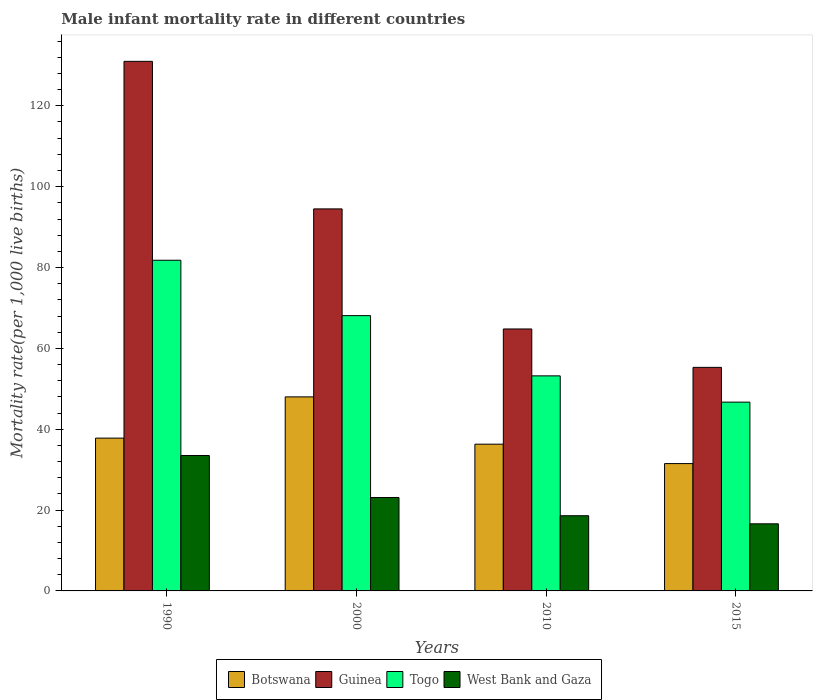How many groups of bars are there?
Offer a very short reply. 4. Are the number of bars on each tick of the X-axis equal?
Provide a short and direct response. Yes. What is the label of the 3rd group of bars from the left?
Offer a terse response. 2010. In how many cases, is the number of bars for a given year not equal to the number of legend labels?
Ensure brevity in your answer.  0. What is the male infant mortality rate in Togo in 2000?
Offer a very short reply. 68.1. Across all years, what is the maximum male infant mortality rate in Botswana?
Provide a succinct answer. 48. Across all years, what is the minimum male infant mortality rate in Botswana?
Your answer should be compact. 31.5. In which year was the male infant mortality rate in Guinea maximum?
Keep it short and to the point. 1990. In which year was the male infant mortality rate in West Bank and Gaza minimum?
Give a very brief answer. 2015. What is the total male infant mortality rate in Guinea in the graph?
Offer a terse response. 345.6. What is the difference between the male infant mortality rate in Togo in 2000 and that in 2015?
Your answer should be very brief. 21.4. What is the difference between the male infant mortality rate in West Bank and Gaza in 2000 and the male infant mortality rate in Guinea in 2015?
Your response must be concise. -32.2. What is the average male infant mortality rate in West Bank and Gaza per year?
Provide a short and direct response. 22.95. In the year 2000, what is the difference between the male infant mortality rate in Togo and male infant mortality rate in Botswana?
Your answer should be very brief. 20.1. In how many years, is the male infant mortality rate in Botswana greater than 72?
Give a very brief answer. 0. What is the ratio of the male infant mortality rate in West Bank and Gaza in 2000 to that in 2015?
Give a very brief answer. 1.39. Is the male infant mortality rate in Guinea in 1990 less than that in 2000?
Provide a short and direct response. No. Is the difference between the male infant mortality rate in Togo in 2000 and 2015 greater than the difference between the male infant mortality rate in Botswana in 2000 and 2015?
Your answer should be very brief. Yes. What is the difference between the highest and the second highest male infant mortality rate in West Bank and Gaza?
Offer a very short reply. 10.4. What is the difference between the highest and the lowest male infant mortality rate in Guinea?
Offer a terse response. 75.7. Is the sum of the male infant mortality rate in Guinea in 1990 and 2010 greater than the maximum male infant mortality rate in Botswana across all years?
Your response must be concise. Yes. What does the 1st bar from the left in 2010 represents?
Provide a short and direct response. Botswana. What does the 4th bar from the right in 1990 represents?
Your answer should be compact. Botswana. How many bars are there?
Your answer should be very brief. 16. Are the values on the major ticks of Y-axis written in scientific E-notation?
Offer a very short reply. No. Does the graph contain any zero values?
Offer a very short reply. No. Where does the legend appear in the graph?
Ensure brevity in your answer.  Bottom center. What is the title of the graph?
Ensure brevity in your answer.  Male infant mortality rate in different countries. Does "Jordan" appear as one of the legend labels in the graph?
Give a very brief answer. No. What is the label or title of the X-axis?
Your response must be concise. Years. What is the label or title of the Y-axis?
Provide a short and direct response. Mortality rate(per 1,0 live births). What is the Mortality rate(per 1,000 live births) in Botswana in 1990?
Keep it short and to the point. 37.8. What is the Mortality rate(per 1,000 live births) of Guinea in 1990?
Provide a succinct answer. 131. What is the Mortality rate(per 1,000 live births) of Togo in 1990?
Provide a succinct answer. 81.8. What is the Mortality rate(per 1,000 live births) of West Bank and Gaza in 1990?
Your response must be concise. 33.5. What is the Mortality rate(per 1,000 live births) in Guinea in 2000?
Provide a succinct answer. 94.5. What is the Mortality rate(per 1,000 live births) in Togo in 2000?
Offer a very short reply. 68.1. What is the Mortality rate(per 1,000 live births) of West Bank and Gaza in 2000?
Your response must be concise. 23.1. What is the Mortality rate(per 1,000 live births) of Botswana in 2010?
Make the answer very short. 36.3. What is the Mortality rate(per 1,000 live births) of Guinea in 2010?
Keep it short and to the point. 64.8. What is the Mortality rate(per 1,000 live births) of Togo in 2010?
Offer a very short reply. 53.2. What is the Mortality rate(per 1,000 live births) in Botswana in 2015?
Offer a terse response. 31.5. What is the Mortality rate(per 1,000 live births) in Guinea in 2015?
Your response must be concise. 55.3. What is the Mortality rate(per 1,000 live births) of Togo in 2015?
Offer a terse response. 46.7. What is the Mortality rate(per 1,000 live births) of West Bank and Gaza in 2015?
Your response must be concise. 16.6. Across all years, what is the maximum Mortality rate(per 1,000 live births) in Guinea?
Keep it short and to the point. 131. Across all years, what is the maximum Mortality rate(per 1,000 live births) of Togo?
Ensure brevity in your answer.  81.8. Across all years, what is the maximum Mortality rate(per 1,000 live births) of West Bank and Gaza?
Keep it short and to the point. 33.5. Across all years, what is the minimum Mortality rate(per 1,000 live births) of Botswana?
Provide a short and direct response. 31.5. Across all years, what is the minimum Mortality rate(per 1,000 live births) of Guinea?
Provide a short and direct response. 55.3. Across all years, what is the minimum Mortality rate(per 1,000 live births) in Togo?
Give a very brief answer. 46.7. What is the total Mortality rate(per 1,000 live births) in Botswana in the graph?
Give a very brief answer. 153.6. What is the total Mortality rate(per 1,000 live births) in Guinea in the graph?
Offer a terse response. 345.6. What is the total Mortality rate(per 1,000 live births) in Togo in the graph?
Give a very brief answer. 249.8. What is the total Mortality rate(per 1,000 live births) in West Bank and Gaza in the graph?
Give a very brief answer. 91.8. What is the difference between the Mortality rate(per 1,000 live births) in Botswana in 1990 and that in 2000?
Your answer should be very brief. -10.2. What is the difference between the Mortality rate(per 1,000 live births) of Guinea in 1990 and that in 2000?
Provide a short and direct response. 36.5. What is the difference between the Mortality rate(per 1,000 live births) in Togo in 1990 and that in 2000?
Your answer should be very brief. 13.7. What is the difference between the Mortality rate(per 1,000 live births) of West Bank and Gaza in 1990 and that in 2000?
Provide a short and direct response. 10.4. What is the difference between the Mortality rate(per 1,000 live births) of Botswana in 1990 and that in 2010?
Ensure brevity in your answer.  1.5. What is the difference between the Mortality rate(per 1,000 live births) in Guinea in 1990 and that in 2010?
Keep it short and to the point. 66.2. What is the difference between the Mortality rate(per 1,000 live births) of Togo in 1990 and that in 2010?
Provide a short and direct response. 28.6. What is the difference between the Mortality rate(per 1,000 live births) in West Bank and Gaza in 1990 and that in 2010?
Make the answer very short. 14.9. What is the difference between the Mortality rate(per 1,000 live births) of Guinea in 1990 and that in 2015?
Provide a short and direct response. 75.7. What is the difference between the Mortality rate(per 1,000 live births) in Togo in 1990 and that in 2015?
Give a very brief answer. 35.1. What is the difference between the Mortality rate(per 1,000 live births) of Botswana in 2000 and that in 2010?
Your response must be concise. 11.7. What is the difference between the Mortality rate(per 1,000 live births) of Guinea in 2000 and that in 2010?
Offer a very short reply. 29.7. What is the difference between the Mortality rate(per 1,000 live births) of Togo in 2000 and that in 2010?
Offer a terse response. 14.9. What is the difference between the Mortality rate(per 1,000 live births) of West Bank and Gaza in 2000 and that in 2010?
Offer a very short reply. 4.5. What is the difference between the Mortality rate(per 1,000 live births) in Botswana in 2000 and that in 2015?
Your answer should be compact. 16.5. What is the difference between the Mortality rate(per 1,000 live births) of Guinea in 2000 and that in 2015?
Your response must be concise. 39.2. What is the difference between the Mortality rate(per 1,000 live births) of Togo in 2000 and that in 2015?
Your answer should be very brief. 21.4. What is the difference between the Mortality rate(per 1,000 live births) in Guinea in 2010 and that in 2015?
Ensure brevity in your answer.  9.5. What is the difference between the Mortality rate(per 1,000 live births) of Togo in 2010 and that in 2015?
Provide a short and direct response. 6.5. What is the difference between the Mortality rate(per 1,000 live births) of Botswana in 1990 and the Mortality rate(per 1,000 live births) of Guinea in 2000?
Provide a short and direct response. -56.7. What is the difference between the Mortality rate(per 1,000 live births) in Botswana in 1990 and the Mortality rate(per 1,000 live births) in Togo in 2000?
Your answer should be compact. -30.3. What is the difference between the Mortality rate(per 1,000 live births) in Botswana in 1990 and the Mortality rate(per 1,000 live births) in West Bank and Gaza in 2000?
Your answer should be very brief. 14.7. What is the difference between the Mortality rate(per 1,000 live births) of Guinea in 1990 and the Mortality rate(per 1,000 live births) of Togo in 2000?
Ensure brevity in your answer.  62.9. What is the difference between the Mortality rate(per 1,000 live births) of Guinea in 1990 and the Mortality rate(per 1,000 live births) of West Bank and Gaza in 2000?
Provide a short and direct response. 107.9. What is the difference between the Mortality rate(per 1,000 live births) in Togo in 1990 and the Mortality rate(per 1,000 live births) in West Bank and Gaza in 2000?
Offer a terse response. 58.7. What is the difference between the Mortality rate(per 1,000 live births) in Botswana in 1990 and the Mortality rate(per 1,000 live births) in Guinea in 2010?
Provide a succinct answer. -27. What is the difference between the Mortality rate(per 1,000 live births) in Botswana in 1990 and the Mortality rate(per 1,000 live births) in Togo in 2010?
Your answer should be compact. -15.4. What is the difference between the Mortality rate(per 1,000 live births) in Guinea in 1990 and the Mortality rate(per 1,000 live births) in Togo in 2010?
Offer a terse response. 77.8. What is the difference between the Mortality rate(per 1,000 live births) in Guinea in 1990 and the Mortality rate(per 1,000 live births) in West Bank and Gaza in 2010?
Make the answer very short. 112.4. What is the difference between the Mortality rate(per 1,000 live births) of Togo in 1990 and the Mortality rate(per 1,000 live births) of West Bank and Gaza in 2010?
Give a very brief answer. 63.2. What is the difference between the Mortality rate(per 1,000 live births) in Botswana in 1990 and the Mortality rate(per 1,000 live births) in Guinea in 2015?
Your answer should be very brief. -17.5. What is the difference between the Mortality rate(per 1,000 live births) in Botswana in 1990 and the Mortality rate(per 1,000 live births) in Togo in 2015?
Keep it short and to the point. -8.9. What is the difference between the Mortality rate(per 1,000 live births) in Botswana in 1990 and the Mortality rate(per 1,000 live births) in West Bank and Gaza in 2015?
Keep it short and to the point. 21.2. What is the difference between the Mortality rate(per 1,000 live births) in Guinea in 1990 and the Mortality rate(per 1,000 live births) in Togo in 2015?
Your answer should be compact. 84.3. What is the difference between the Mortality rate(per 1,000 live births) in Guinea in 1990 and the Mortality rate(per 1,000 live births) in West Bank and Gaza in 2015?
Offer a terse response. 114.4. What is the difference between the Mortality rate(per 1,000 live births) of Togo in 1990 and the Mortality rate(per 1,000 live births) of West Bank and Gaza in 2015?
Your answer should be compact. 65.2. What is the difference between the Mortality rate(per 1,000 live births) in Botswana in 2000 and the Mortality rate(per 1,000 live births) in Guinea in 2010?
Provide a short and direct response. -16.8. What is the difference between the Mortality rate(per 1,000 live births) of Botswana in 2000 and the Mortality rate(per 1,000 live births) of West Bank and Gaza in 2010?
Your answer should be very brief. 29.4. What is the difference between the Mortality rate(per 1,000 live births) of Guinea in 2000 and the Mortality rate(per 1,000 live births) of Togo in 2010?
Ensure brevity in your answer.  41.3. What is the difference between the Mortality rate(per 1,000 live births) in Guinea in 2000 and the Mortality rate(per 1,000 live births) in West Bank and Gaza in 2010?
Provide a short and direct response. 75.9. What is the difference between the Mortality rate(per 1,000 live births) of Togo in 2000 and the Mortality rate(per 1,000 live births) of West Bank and Gaza in 2010?
Your answer should be compact. 49.5. What is the difference between the Mortality rate(per 1,000 live births) in Botswana in 2000 and the Mortality rate(per 1,000 live births) in Togo in 2015?
Your answer should be compact. 1.3. What is the difference between the Mortality rate(per 1,000 live births) in Botswana in 2000 and the Mortality rate(per 1,000 live births) in West Bank and Gaza in 2015?
Offer a terse response. 31.4. What is the difference between the Mortality rate(per 1,000 live births) of Guinea in 2000 and the Mortality rate(per 1,000 live births) of Togo in 2015?
Your answer should be very brief. 47.8. What is the difference between the Mortality rate(per 1,000 live births) in Guinea in 2000 and the Mortality rate(per 1,000 live births) in West Bank and Gaza in 2015?
Provide a succinct answer. 77.9. What is the difference between the Mortality rate(per 1,000 live births) in Togo in 2000 and the Mortality rate(per 1,000 live births) in West Bank and Gaza in 2015?
Offer a terse response. 51.5. What is the difference between the Mortality rate(per 1,000 live births) in Botswana in 2010 and the Mortality rate(per 1,000 live births) in Guinea in 2015?
Give a very brief answer. -19. What is the difference between the Mortality rate(per 1,000 live births) of Botswana in 2010 and the Mortality rate(per 1,000 live births) of West Bank and Gaza in 2015?
Your response must be concise. 19.7. What is the difference between the Mortality rate(per 1,000 live births) in Guinea in 2010 and the Mortality rate(per 1,000 live births) in West Bank and Gaza in 2015?
Your response must be concise. 48.2. What is the difference between the Mortality rate(per 1,000 live births) in Togo in 2010 and the Mortality rate(per 1,000 live births) in West Bank and Gaza in 2015?
Offer a very short reply. 36.6. What is the average Mortality rate(per 1,000 live births) of Botswana per year?
Your response must be concise. 38.4. What is the average Mortality rate(per 1,000 live births) in Guinea per year?
Offer a terse response. 86.4. What is the average Mortality rate(per 1,000 live births) in Togo per year?
Provide a succinct answer. 62.45. What is the average Mortality rate(per 1,000 live births) in West Bank and Gaza per year?
Offer a terse response. 22.95. In the year 1990, what is the difference between the Mortality rate(per 1,000 live births) of Botswana and Mortality rate(per 1,000 live births) of Guinea?
Provide a succinct answer. -93.2. In the year 1990, what is the difference between the Mortality rate(per 1,000 live births) in Botswana and Mortality rate(per 1,000 live births) in Togo?
Provide a succinct answer. -44. In the year 1990, what is the difference between the Mortality rate(per 1,000 live births) in Guinea and Mortality rate(per 1,000 live births) in Togo?
Your answer should be compact. 49.2. In the year 1990, what is the difference between the Mortality rate(per 1,000 live births) of Guinea and Mortality rate(per 1,000 live births) of West Bank and Gaza?
Your answer should be compact. 97.5. In the year 1990, what is the difference between the Mortality rate(per 1,000 live births) of Togo and Mortality rate(per 1,000 live births) of West Bank and Gaza?
Provide a succinct answer. 48.3. In the year 2000, what is the difference between the Mortality rate(per 1,000 live births) in Botswana and Mortality rate(per 1,000 live births) in Guinea?
Your answer should be very brief. -46.5. In the year 2000, what is the difference between the Mortality rate(per 1,000 live births) of Botswana and Mortality rate(per 1,000 live births) of Togo?
Provide a succinct answer. -20.1. In the year 2000, what is the difference between the Mortality rate(per 1,000 live births) of Botswana and Mortality rate(per 1,000 live births) of West Bank and Gaza?
Your answer should be very brief. 24.9. In the year 2000, what is the difference between the Mortality rate(per 1,000 live births) in Guinea and Mortality rate(per 1,000 live births) in Togo?
Your response must be concise. 26.4. In the year 2000, what is the difference between the Mortality rate(per 1,000 live births) in Guinea and Mortality rate(per 1,000 live births) in West Bank and Gaza?
Offer a terse response. 71.4. In the year 2000, what is the difference between the Mortality rate(per 1,000 live births) in Togo and Mortality rate(per 1,000 live births) in West Bank and Gaza?
Offer a very short reply. 45. In the year 2010, what is the difference between the Mortality rate(per 1,000 live births) in Botswana and Mortality rate(per 1,000 live births) in Guinea?
Keep it short and to the point. -28.5. In the year 2010, what is the difference between the Mortality rate(per 1,000 live births) in Botswana and Mortality rate(per 1,000 live births) in Togo?
Ensure brevity in your answer.  -16.9. In the year 2010, what is the difference between the Mortality rate(per 1,000 live births) in Botswana and Mortality rate(per 1,000 live births) in West Bank and Gaza?
Make the answer very short. 17.7. In the year 2010, what is the difference between the Mortality rate(per 1,000 live births) in Guinea and Mortality rate(per 1,000 live births) in West Bank and Gaza?
Provide a succinct answer. 46.2. In the year 2010, what is the difference between the Mortality rate(per 1,000 live births) of Togo and Mortality rate(per 1,000 live births) of West Bank and Gaza?
Your response must be concise. 34.6. In the year 2015, what is the difference between the Mortality rate(per 1,000 live births) of Botswana and Mortality rate(per 1,000 live births) of Guinea?
Provide a succinct answer. -23.8. In the year 2015, what is the difference between the Mortality rate(per 1,000 live births) in Botswana and Mortality rate(per 1,000 live births) in Togo?
Your response must be concise. -15.2. In the year 2015, what is the difference between the Mortality rate(per 1,000 live births) in Botswana and Mortality rate(per 1,000 live births) in West Bank and Gaza?
Keep it short and to the point. 14.9. In the year 2015, what is the difference between the Mortality rate(per 1,000 live births) of Guinea and Mortality rate(per 1,000 live births) of Togo?
Provide a short and direct response. 8.6. In the year 2015, what is the difference between the Mortality rate(per 1,000 live births) of Guinea and Mortality rate(per 1,000 live births) of West Bank and Gaza?
Your answer should be very brief. 38.7. In the year 2015, what is the difference between the Mortality rate(per 1,000 live births) of Togo and Mortality rate(per 1,000 live births) of West Bank and Gaza?
Offer a very short reply. 30.1. What is the ratio of the Mortality rate(per 1,000 live births) in Botswana in 1990 to that in 2000?
Keep it short and to the point. 0.79. What is the ratio of the Mortality rate(per 1,000 live births) of Guinea in 1990 to that in 2000?
Ensure brevity in your answer.  1.39. What is the ratio of the Mortality rate(per 1,000 live births) in Togo in 1990 to that in 2000?
Give a very brief answer. 1.2. What is the ratio of the Mortality rate(per 1,000 live births) of West Bank and Gaza in 1990 to that in 2000?
Offer a very short reply. 1.45. What is the ratio of the Mortality rate(per 1,000 live births) in Botswana in 1990 to that in 2010?
Provide a short and direct response. 1.04. What is the ratio of the Mortality rate(per 1,000 live births) in Guinea in 1990 to that in 2010?
Provide a short and direct response. 2.02. What is the ratio of the Mortality rate(per 1,000 live births) in Togo in 1990 to that in 2010?
Offer a terse response. 1.54. What is the ratio of the Mortality rate(per 1,000 live births) in West Bank and Gaza in 1990 to that in 2010?
Offer a terse response. 1.8. What is the ratio of the Mortality rate(per 1,000 live births) of Guinea in 1990 to that in 2015?
Your answer should be very brief. 2.37. What is the ratio of the Mortality rate(per 1,000 live births) in Togo in 1990 to that in 2015?
Your response must be concise. 1.75. What is the ratio of the Mortality rate(per 1,000 live births) of West Bank and Gaza in 1990 to that in 2015?
Provide a short and direct response. 2.02. What is the ratio of the Mortality rate(per 1,000 live births) of Botswana in 2000 to that in 2010?
Give a very brief answer. 1.32. What is the ratio of the Mortality rate(per 1,000 live births) in Guinea in 2000 to that in 2010?
Your answer should be compact. 1.46. What is the ratio of the Mortality rate(per 1,000 live births) in Togo in 2000 to that in 2010?
Provide a short and direct response. 1.28. What is the ratio of the Mortality rate(per 1,000 live births) in West Bank and Gaza in 2000 to that in 2010?
Make the answer very short. 1.24. What is the ratio of the Mortality rate(per 1,000 live births) in Botswana in 2000 to that in 2015?
Offer a very short reply. 1.52. What is the ratio of the Mortality rate(per 1,000 live births) in Guinea in 2000 to that in 2015?
Your answer should be compact. 1.71. What is the ratio of the Mortality rate(per 1,000 live births) of Togo in 2000 to that in 2015?
Offer a terse response. 1.46. What is the ratio of the Mortality rate(per 1,000 live births) of West Bank and Gaza in 2000 to that in 2015?
Your answer should be compact. 1.39. What is the ratio of the Mortality rate(per 1,000 live births) in Botswana in 2010 to that in 2015?
Offer a terse response. 1.15. What is the ratio of the Mortality rate(per 1,000 live births) of Guinea in 2010 to that in 2015?
Your answer should be compact. 1.17. What is the ratio of the Mortality rate(per 1,000 live births) in Togo in 2010 to that in 2015?
Make the answer very short. 1.14. What is the ratio of the Mortality rate(per 1,000 live births) of West Bank and Gaza in 2010 to that in 2015?
Your answer should be compact. 1.12. What is the difference between the highest and the second highest Mortality rate(per 1,000 live births) of Botswana?
Offer a terse response. 10.2. What is the difference between the highest and the second highest Mortality rate(per 1,000 live births) in Guinea?
Your answer should be compact. 36.5. What is the difference between the highest and the second highest Mortality rate(per 1,000 live births) in Togo?
Provide a short and direct response. 13.7. What is the difference between the highest and the second highest Mortality rate(per 1,000 live births) of West Bank and Gaza?
Keep it short and to the point. 10.4. What is the difference between the highest and the lowest Mortality rate(per 1,000 live births) of Guinea?
Your response must be concise. 75.7. What is the difference between the highest and the lowest Mortality rate(per 1,000 live births) in Togo?
Ensure brevity in your answer.  35.1. 